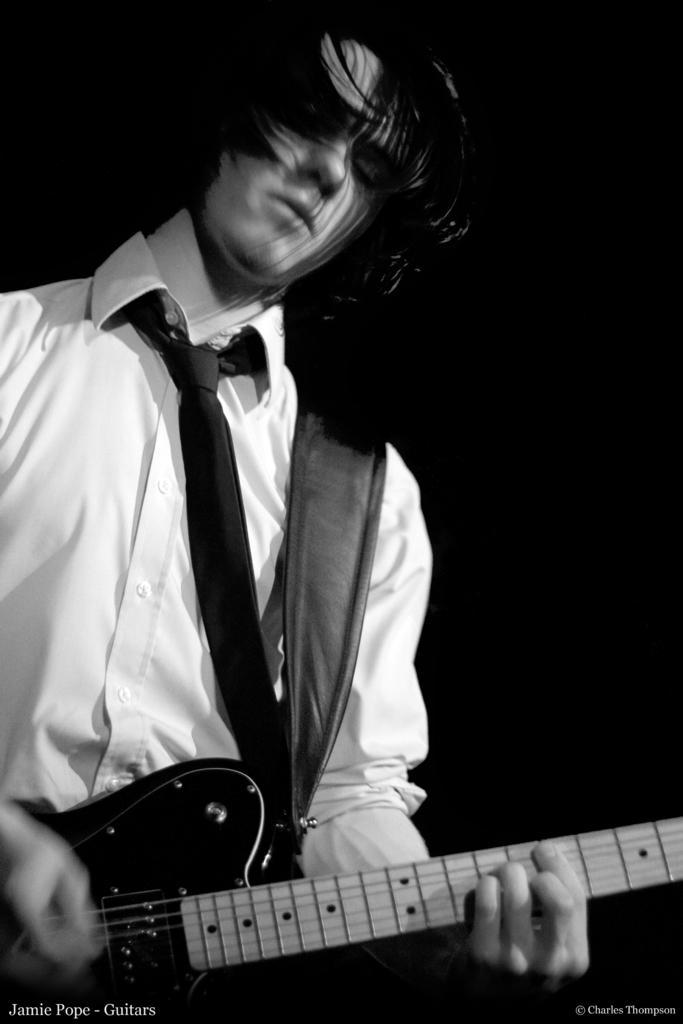What is the color scheme of the image? The image is black and white. Who is the main subject in the image? There is a man in the middle of the image. What is the man holding in the image? The man is holding a guitar. What is the man doing with the guitar? The man is playing the guitar. What book is the man reading in the image? There is no book present in the image, and the man is playing the guitar, not reading. What type of thread is being used to sew the man's skin in the image? There is no sewing or thread visible in the image, and the man is playing the guitar, not undergoing any medical procedure. 